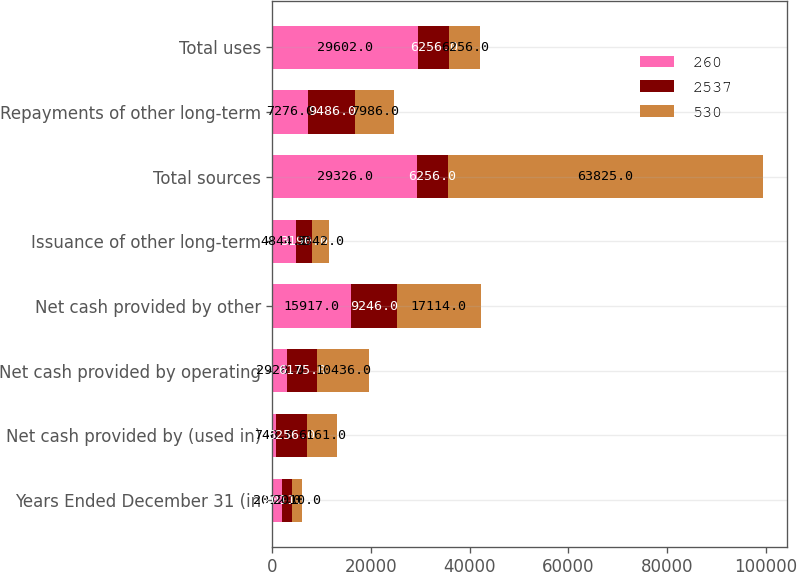Convert chart. <chart><loc_0><loc_0><loc_500><loc_500><stacked_bar_chart><ecel><fcel>Years Ended December 31 (in<fcel>Net cash provided by (used in)<fcel>Net cash provided by operating<fcel>Net cash provided by other<fcel>Issuance of other long-term<fcel>Total sources<fcel>Repayments of other long-term<fcel>Total uses<nl><fcel>260<fcel>2012<fcel>748<fcel>2928<fcel>15917<fcel>4844<fcel>29326<fcel>7276<fcel>29602<nl><fcel>2537<fcel>2011<fcel>6256<fcel>6175<fcel>9246<fcel>3190<fcel>6256<fcel>9486<fcel>6256<nl><fcel>530<fcel>2010<fcel>6161<fcel>10436<fcel>17114<fcel>3342<fcel>63825<fcel>7986<fcel>6256<nl></chart> 